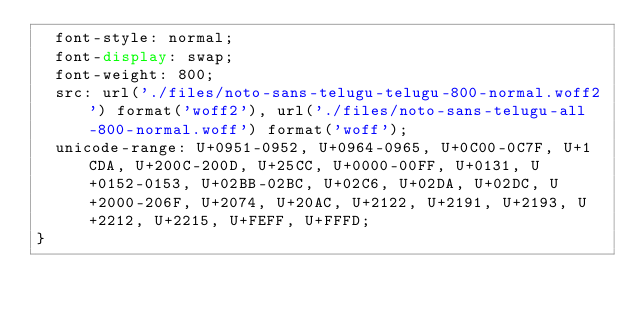Convert code to text. <code><loc_0><loc_0><loc_500><loc_500><_CSS_>  font-style: normal;
  font-display: swap;
  font-weight: 800;
  src: url('./files/noto-sans-telugu-telugu-800-normal.woff2') format('woff2'), url('./files/noto-sans-telugu-all-800-normal.woff') format('woff');
  unicode-range: U+0951-0952, U+0964-0965, U+0C00-0C7F, U+1CDA, U+200C-200D, U+25CC, U+0000-00FF, U+0131, U+0152-0153, U+02BB-02BC, U+02C6, U+02DA, U+02DC, U+2000-206F, U+2074, U+20AC, U+2122, U+2191, U+2193, U+2212, U+2215, U+FEFF, U+FFFD;
}
</code> 